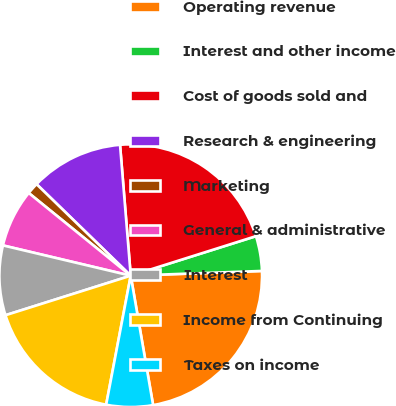<chart> <loc_0><loc_0><loc_500><loc_500><pie_chart><fcel>Year Ended December 31<fcel>Operating revenue<fcel>Interest and other income<fcel>Cost of goods sold and<fcel>Research & engineering<fcel>Marketing<fcel>General & administrative<fcel>Interest<fcel>Income from Continuing<fcel>Taxes on income<nl><fcel>0.0%<fcel>22.85%<fcel>4.29%<fcel>21.43%<fcel>11.43%<fcel>1.43%<fcel>7.14%<fcel>8.57%<fcel>17.14%<fcel>5.72%<nl></chart> 